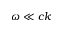<formula> <loc_0><loc_0><loc_500><loc_500>\omega \ll c k</formula> 